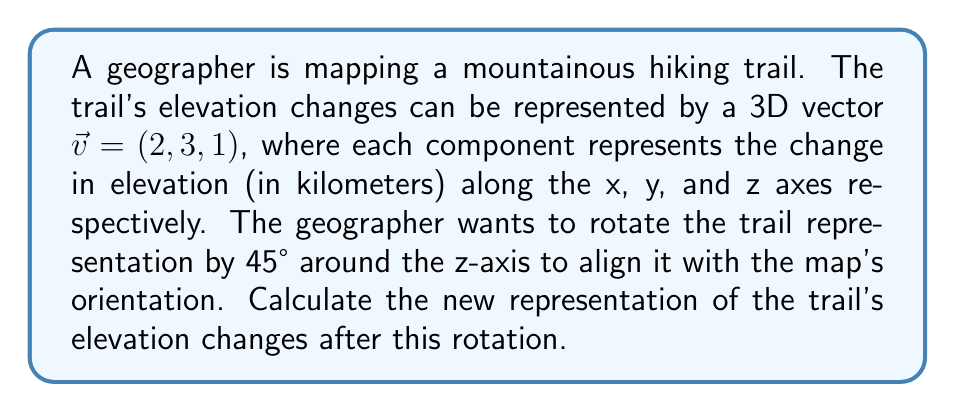Help me with this question. To solve this problem, we need to use a rotation matrix and apply it to the given vector. Here's the step-by-step process:

1) The rotation matrix for a 45° rotation around the z-axis is:

   $$R_z(45°) = \begin{pmatrix}
   \cos 45° & -\sin 45° & 0 \\
   \sin 45° & \cos 45° & 0 \\
   0 & 0 & 1
   \end{pmatrix}$$

2) We know that $\cos 45° = \sin 45° = \frac{1}{\sqrt{2}}$. Substituting these values:

   $$R_z(45°) = \begin{pmatrix}
   \frac{1}{\sqrt{2}} & -\frac{1}{\sqrt{2}} & 0 \\
   \frac{1}{\sqrt{2}} & \frac{1}{\sqrt{2}} & 0 \\
   0 & 0 & 1
   \end{pmatrix}$$

3) To apply the rotation, we multiply the matrix by the vector:

   $$\begin{pmatrix}
   \frac{1}{\sqrt{2}} & -\frac{1}{\sqrt{2}} & 0 \\
   \frac{1}{\sqrt{2}} & \frac{1}{\sqrt{2}} & 0 \\
   0 & 0 & 1
   \end{pmatrix} \begin{pmatrix} 2 \\ 3 \\ 1 \end{pmatrix}$$

4) Performing the matrix multiplication:

   $$\begin{pmatrix}
   \frac{1}{\sqrt{2}}(2) + (-\frac{1}{\sqrt{2}})(3) + 0(1) \\
   \frac{1}{\sqrt{2}}(2) + \frac{1}{\sqrt{2}}(3) + 0(1) \\
   0(2) + 0(3) + 1(1)
   \end{pmatrix}$$

5) Simplifying:

   $$\begin{pmatrix}
   \frac{2-3}{\sqrt{2}} \\
   \frac{2+3}{\sqrt{2}} \\
   1
   \end{pmatrix} = \begin{pmatrix}
   -\frac{1}{\sqrt{2}} \\
   \frac{5}{\sqrt{2}} \\
   1
   \end{pmatrix}$$

Therefore, the new representation of the trail's elevation changes after rotation is $(-\frac{1}{\sqrt{2}}, \frac{5}{\sqrt{2}}, 1)$.
Answer: $(-\frac{1}{\sqrt{2}}, \frac{5}{\sqrt{2}}, 1)$ 